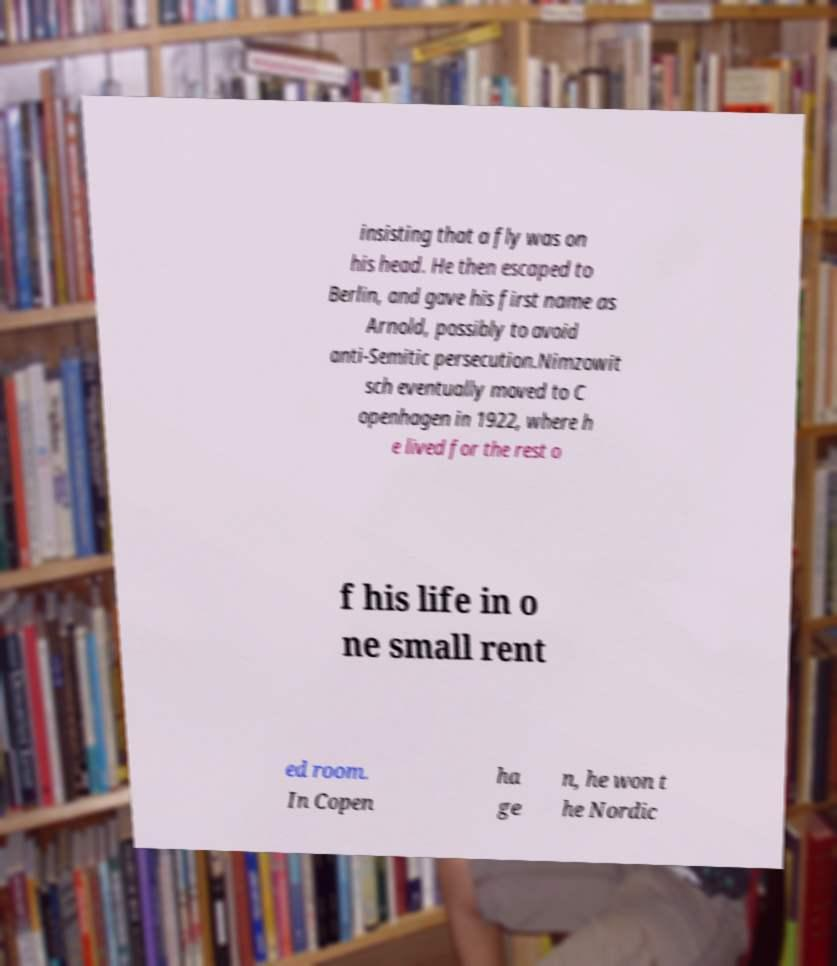Could you extract and type out the text from this image? insisting that a fly was on his head. He then escaped to Berlin, and gave his first name as Arnold, possibly to avoid anti-Semitic persecution.Nimzowit sch eventually moved to C openhagen in 1922, where h e lived for the rest o f his life in o ne small rent ed room. In Copen ha ge n, he won t he Nordic 